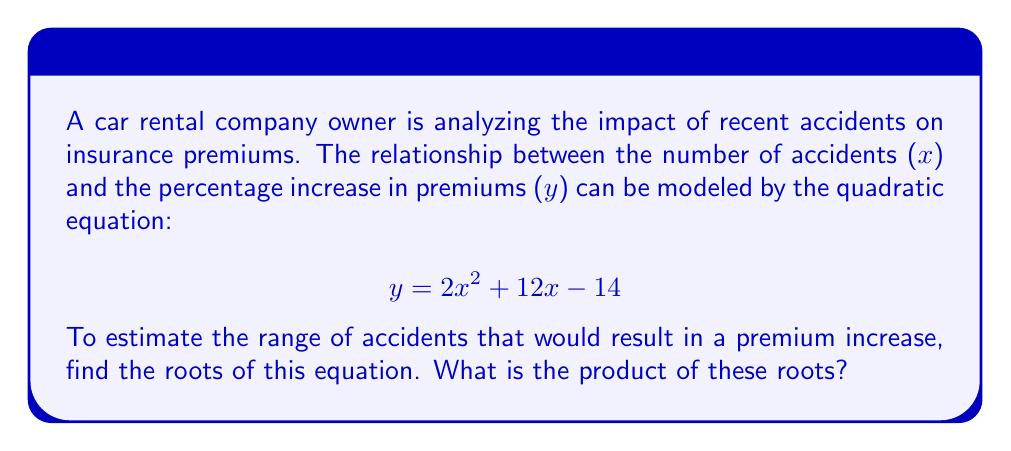Solve this math problem. To solve this problem, we need to find the roots of the quadratic equation. The roots represent the x-values (number of accidents) where y (percentage increase in premiums) equals zero.

1) First, we set the equation equal to zero:
   $$ 2x^2 + 12x - 14 = 0 $$

2) We can solve this using the quadratic formula: $x = \frac{-b \pm \sqrt{b^2 - 4ac}}{2a}$
   Where $a = 2$, $b = 12$, and $c = -14$

3) Substituting these values:
   $$ x = \frac{-12 \pm \sqrt{12^2 - 4(2)(-14)}}{2(2)} $$

4) Simplify under the square root:
   $$ x = \frac{-12 \pm \sqrt{144 + 112}}{4} = \frac{-12 \pm \sqrt{256}}{4} = \frac{-12 \pm 16}{4} $$

5) This gives us two solutions:
   $$ x_1 = \frac{-12 + 16}{4} = \frac{4}{4} = 1 $$
   $$ x_2 = \frac{-12 - 16}{4} = \frac{-28}{4} = -7 $$

6) The product of the roots is:
   $$ 1 \times (-7) = -7 $$

This result indicates that premium increases would occur for any number of accidents between -7 and 1 (excluding these values). However, since negative accidents don't make sense in this context, the practical interpretation is that premiums would increase for any number of accidents up to 1.
Answer: $-7$ 